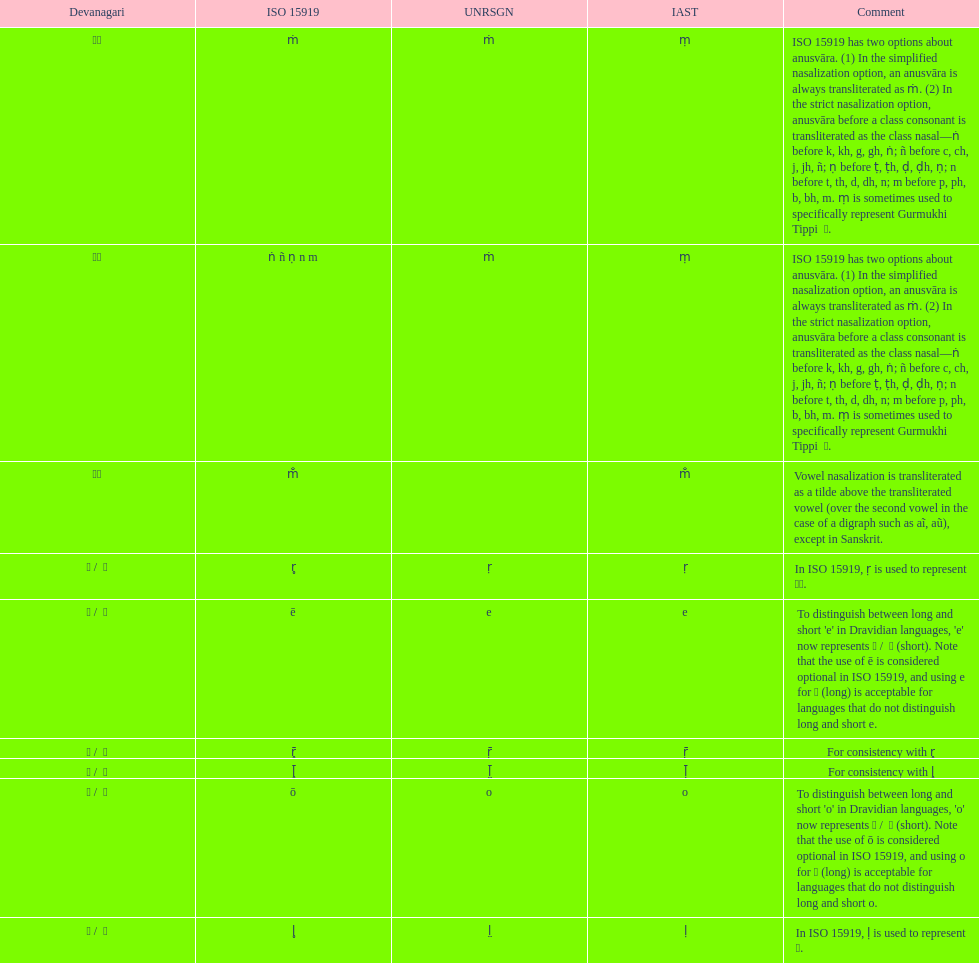Which devanagari transliteration is listed on the top of the table? ए / े. 